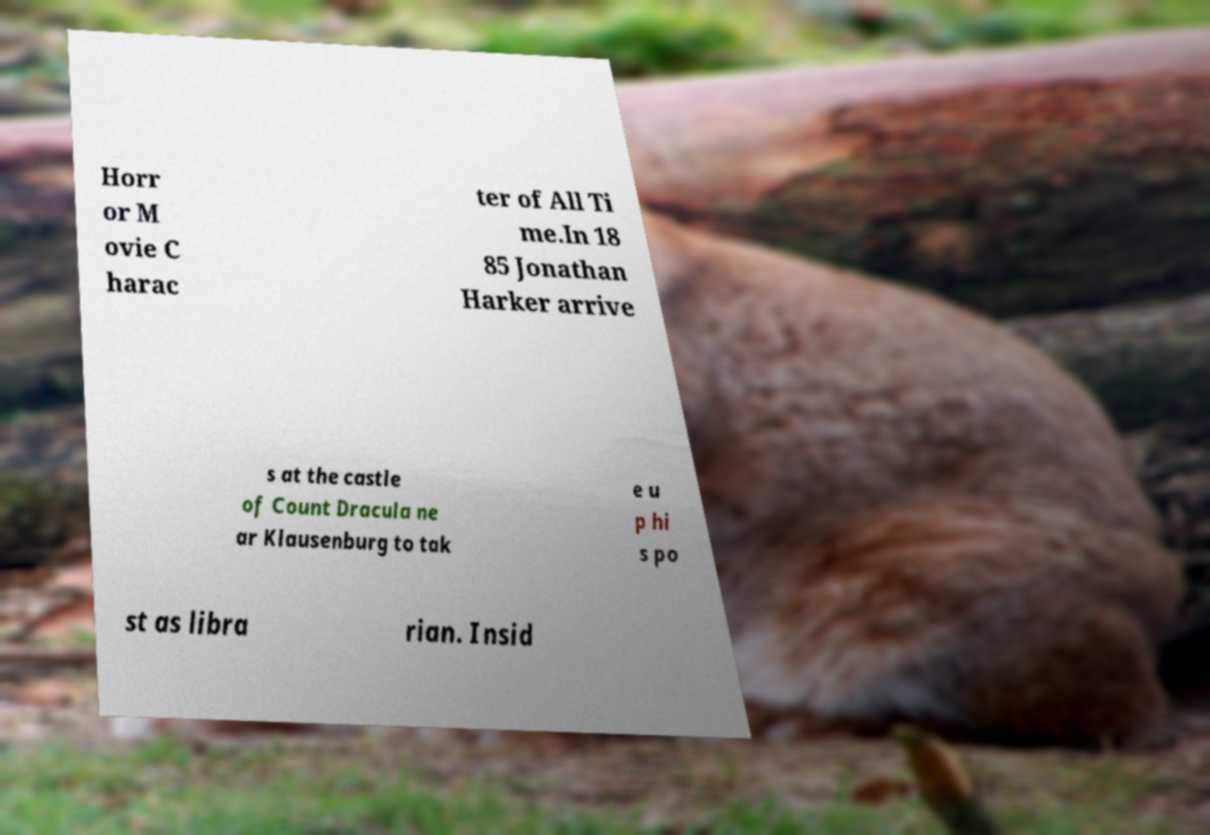What messages or text are displayed in this image? I need them in a readable, typed format. Horr or M ovie C harac ter of All Ti me.In 18 85 Jonathan Harker arrive s at the castle of Count Dracula ne ar Klausenburg to tak e u p hi s po st as libra rian. Insid 